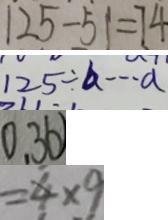<formula> <loc_0><loc_0><loc_500><loc_500>1 2 5 - 5 1 = 7 4 
 1 2 5 \div b \cdots a 
 0 . 3 6 
 = 4 \times 9</formula> 